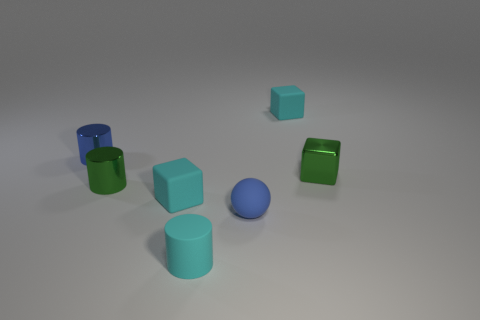Subtract all green cubes. How many cubes are left? 2 Subtract all cyan blocks. How many blocks are left? 1 Add 1 small cyan blocks. How many objects exist? 8 Subtract all small purple metal balls. Subtract all cyan cylinders. How many objects are left? 6 Add 2 cyan cylinders. How many cyan cylinders are left? 3 Add 4 blocks. How many blocks exist? 7 Subtract 0 yellow spheres. How many objects are left? 7 Subtract all balls. How many objects are left? 6 Subtract 1 cylinders. How many cylinders are left? 2 Subtract all gray cylinders. Subtract all yellow balls. How many cylinders are left? 3 